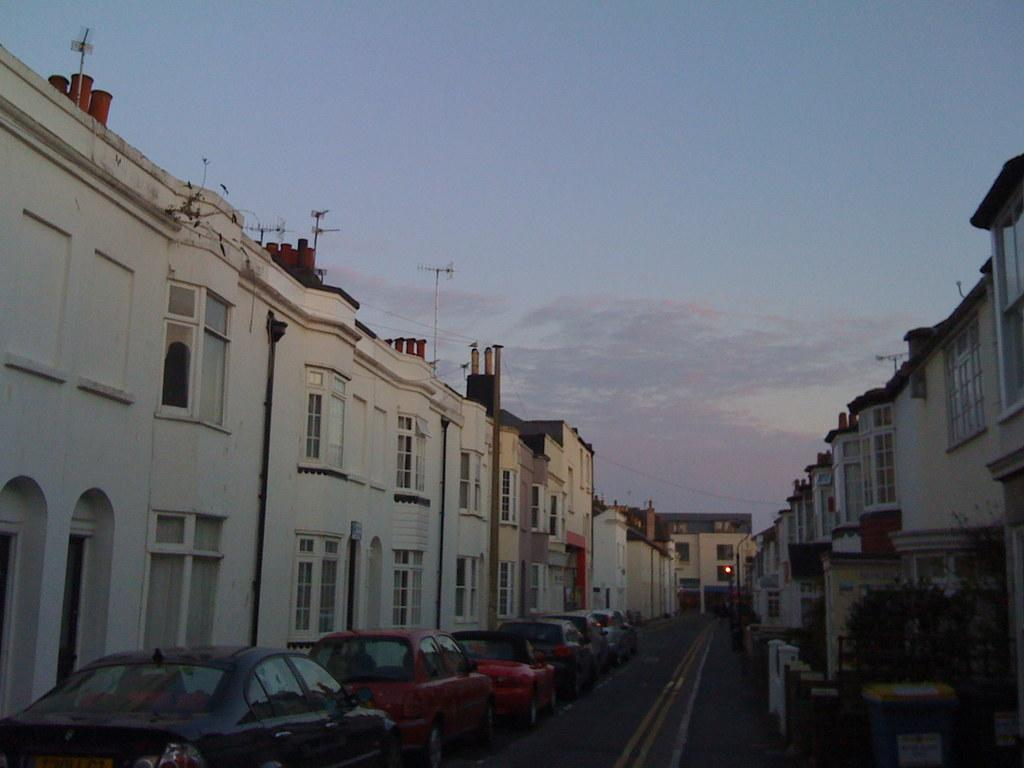What can be seen in the sky in the image? The sky with clouds is visible in the image. What type of structures are present in the image? There are buildings in the image. What are the poles supporting in the image? Electric cables are visible in the image, which are supported by the poles. What type of vegetation is present in the image? Plants are present in the image. What is moving on the road in the image? Motor vehicles are on the road in the image. Where is the boy playing with the tank in the image? There is no boy or tank present in the image. What type of smoke is coming out of the plants in the image? There is no smoke coming out of the plants in the image; they are just plants. 